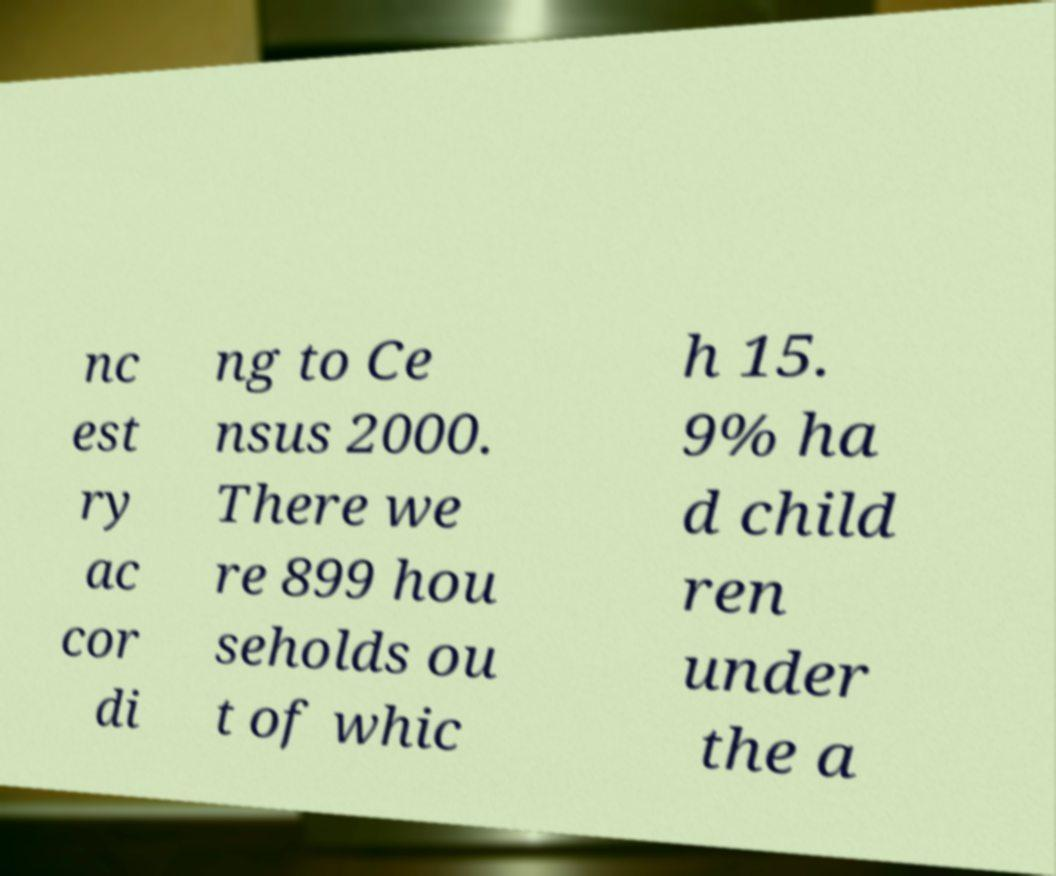Please read and relay the text visible in this image. What does it say? nc est ry ac cor di ng to Ce nsus 2000. There we re 899 hou seholds ou t of whic h 15. 9% ha d child ren under the a 